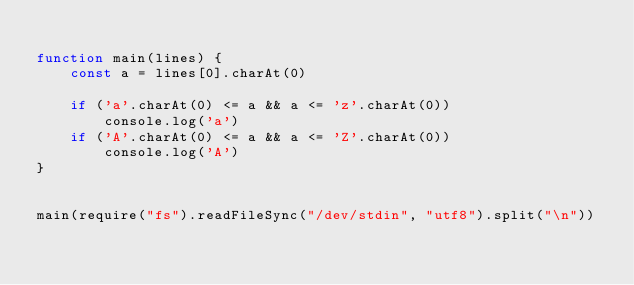Convert code to text. <code><loc_0><loc_0><loc_500><loc_500><_JavaScript_>
function main(lines) {
    const a = lines[0].charAt(0)

    if ('a'.charAt(0) <= a && a <= 'z'.charAt(0))
	    console.log('a')
    if ('A'.charAt(0) <= a && a <= 'Z'.charAt(0))
	    console.log('A')
}


main(require("fs").readFileSync("/dev/stdin", "utf8").split("\n"))
</code> 